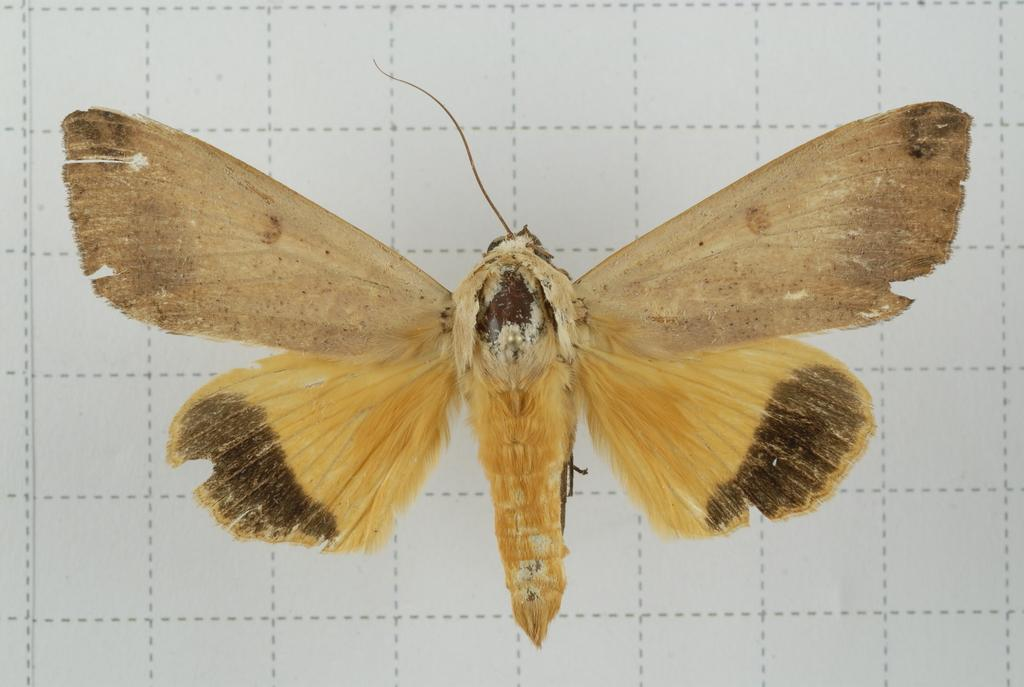What is the main subject of the image? There is a butterfly in the image. What is the background or surface on which the butterfly is resting? The butterfly is on a white surface. Can you describe the white surface in more detail? The white surface has dotted boxes. What type of battle is taking place on the bed in the image? There is no bed or battle present in the image; it features a butterfly on a white surface with dotted boxes. How much sand can be seen in the image? There is no sand present in the image. 